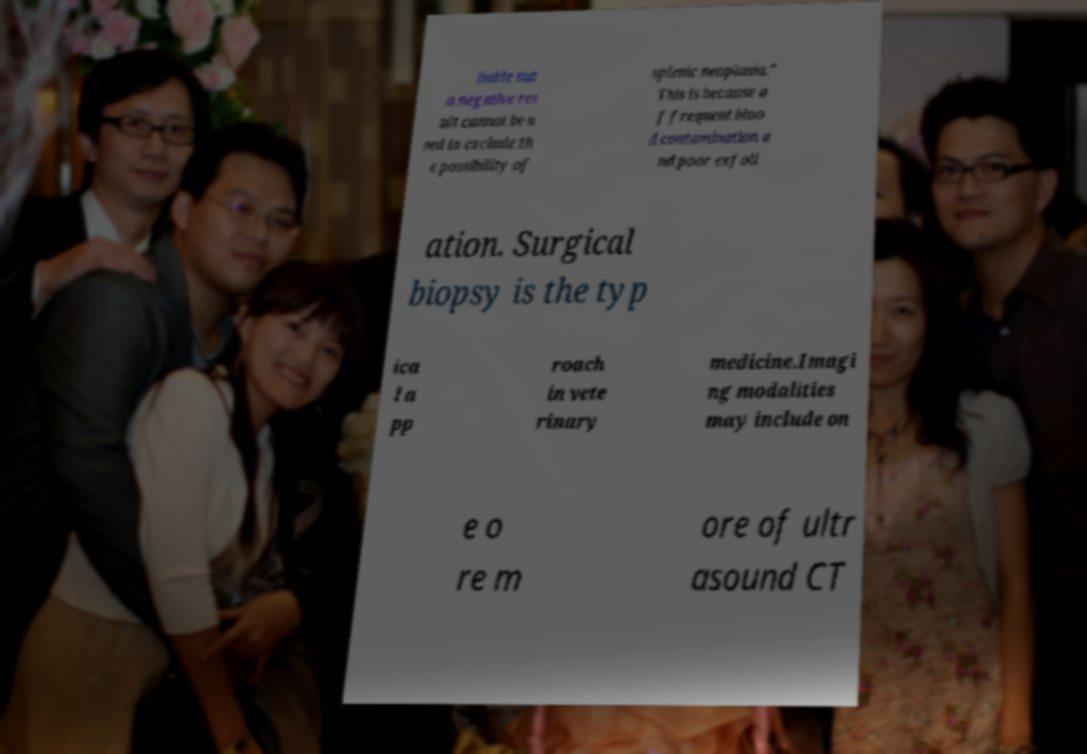I need the written content from this picture converted into text. Can you do that? liable but a negative res ult cannot be u sed to exclude th e possibility of splenic neoplasia." This is because o f frequent bloo d contamination a nd poor exfoli ation. Surgical biopsy is the typ ica l a pp roach in vete rinary medicine.Imagi ng modalities may include on e o re m ore of ultr asound CT 